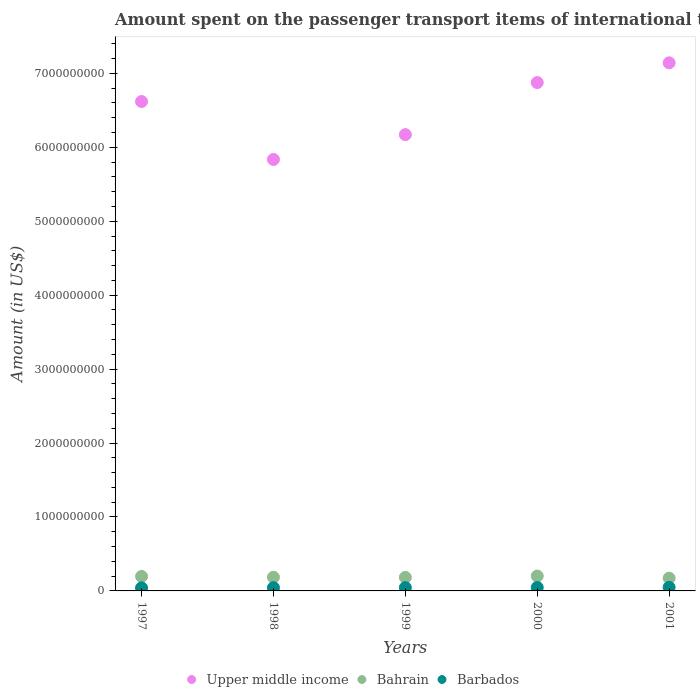Is the number of dotlines equal to the number of legend labels?
Make the answer very short. Yes. What is the amount spent on the passenger transport items of international tourists in Bahrain in 1999?
Offer a terse response. 1.83e+08. Across all years, what is the maximum amount spent on the passenger transport items of international tourists in Barbados?
Offer a terse response. 4.80e+07. Across all years, what is the minimum amount spent on the passenger transport items of international tourists in Upper middle income?
Provide a succinct answer. 5.84e+09. What is the total amount spent on the passenger transport items of international tourists in Bahrain in the graph?
Make the answer very short. 9.38e+08. What is the difference between the amount spent on the passenger transport items of international tourists in Barbados in 1997 and the amount spent on the passenger transport items of international tourists in Upper middle income in 2000?
Provide a short and direct response. -6.83e+09. What is the average amount spent on the passenger transport items of international tourists in Barbados per year?
Keep it short and to the point. 4.50e+07. In the year 1999, what is the difference between the amount spent on the passenger transport items of international tourists in Bahrain and amount spent on the passenger transport items of international tourists in Upper middle income?
Provide a succinct answer. -5.99e+09. In how many years, is the amount spent on the passenger transport items of international tourists in Barbados greater than 4800000000 US$?
Give a very brief answer. 0. What is the ratio of the amount spent on the passenger transport items of international tourists in Upper middle income in 1997 to that in 2000?
Provide a short and direct response. 0.96. Is the amount spent on the passenger transport items of international tourists in Bahrain in 1999 less than that in 2001?
Offer a very short reply. No. Is the difference between the amount spent on the passenger transport items of international tourists in Bahrain in 1997 and 1998 greater than the difference between the amount spent on the passenger transport items of international tourists in Upper middle income in 1997 and 1998?
Offer a very short reply. No. What is the difference between the highest and the second highest amount spent on the passenger transport items of international tourists in Bahrain?
Give a very brief answer. 5.00e+06. In how many years, is the amount spent on the passenger transport items of international tourists in Barbados greater than the average amount spent on the passenger transport items of international tourists in Barbados taken over all years?
Offer a very short reply. 2. Is the sum of the amount spent on the passenger transport items of international tourists in Barbados in 1997 and 2001 greater than the maximum amount spent on the passenger transport items of international tourists in Upper middle income across all years?
Give a very brief answer. No. Is it the case that in every year, the sum of the amount spent on the passenger transport items of international tourists in Barbados and amount spent on the passenger transport items of international tourists in Bahrain  is greater than the amount spent on the passenger transport items of international tourists in Upper middle income?
Make the answer very short. No. Is the amount spent on the passenger transport items of international tourists in Barbados strictly greater than the amount spent on the passenger transport items of international tourists in Upper middle income over the years?
Offer a terse response. No. What is the difference between two consecutive major ticks on the Y-axis?
Offer a very short reply. 1.00e+09. Are the values on the major ticks of Y-axis written in scientific E-notation?
Provide a succinct answer. No. Does the graph contain any zero values?
Make the answer very short. No. How are the legend labels stacked?
Your answer should be compact. Horizontal. What is the title of the graph?
Provide a succinct answer. Amount spent on the passenger transport items of international tourists. What is the Amount (in US$) of Upper middle income in 1997?
Your answer should be very brief. 6.62e+09. What is the Amount (in US$) in Bahrain in 1997?
Keep it short and to the point. 1.96e+08. What is the Amount (in US$) in Barbados in 1997?
Offer a terse response. 4.10e+07. What is the Amount (in US$) of Upper middle income in 1998?
Provide a succinct answer. 5.84e+09. What is the Amount (in US$) in Bahrain in 1998?
Provide a short and direct response. 1.85e+08. What is the Amount (in US$) of Barbados in 1998?
Your answer should be compact. 4.40e+07. What is the Amount (in US$) of Upper middle income in 1999?
Your answer should be very brief. 6.17e+09. What is the Amount (in US$) in Bahrain in 1999?
Offer a terse response. 1.83e+08. What is the Amount (in US$) of Barbados in 1999?
Offer a terse response. 4.50e+07. What is the Amount (in US$) in Upper middle income in 2000?
Your answer should be compact. 6.88e+09. What is the Amount (in US$) in Bahrain in 2000?
Your answer should be compact. 2.01e+08. What is the Amount (in US$) of Barbados in 2000?
Your answer should be compact. 4.70e+07. What is the Amount (in US$) in Upper middle income in 2001?
Provide a short and direct response. 7.14e+09. What is the Amount (in US$) of Bahrain in 2001?
Give a very brief answer. 1.73e+08. What is the Amount (in US$) of Barbados in 2001?
Provide a succinct answer. 4.80e+07. Across all years, what is the maximum Amount (in US$) of Upper middle income?
Provide a short and direct response. 7.14e+09. Across all years, what is the maximum Amount (in US$) in Bahrain?
Your response must be concise. 2.01e+08. Across all years, what is the maximum Amount (in US$) of Barbados?
Offer a very short reply. 4.80e+07. Across all years, what is the minimum Amount (in US$) of Upper middle income?
Your answer should be compact. 5.84e+09. Across all years, what is the minimum Amount (in US$) in Bahrain?
Offer a very short reply. 1.73e+08. Across all years, what is the minimum Amount (in US$) of Barbados?
Provide a succinct answer. 4.10e+07. What is the total Amount (in US$) in Upper middle income in the graph?
Offer a very short reply. 3.26e+1. What is the total Amount (in US$) in Bahrain in the graph?
Ensure brevity in your answer.  9.38e+08. What is the total Amount (in US$) of Barbados in the graph?
Offer a terse response. 2.25e+08. What is the difference between the Amount (in US$) in Upper middle income in 1997 and that in 1998?
Your answer should be very brief. 7.84e+08. What is the difference between the Amount (in US$) of Bahrain in 1997 and that in 1998?
Your response must be concise. 1.10e+07. What is the difference between the Amount (in US$) of Upper middle income in 1997 and that in 1999?
Your answer should be compact. 4.48e+08. What is the difference between the Amount (in US$) in Bahrain in 1997 and that in 1999?
Ensure brevity in your answer.  1.30e+07. What is the difference between the Amount (in US$) of Barbados in 1997 and that in 1999?
Your answer should be compact. -4.00e+06. What is the difference between the Amount (in US$) of Upper middle income in 1997 and that in 2000?
Offer a terse response. -2.57e+08. What is the difference between the Amount (in US$) in Bahrain in 1997 and that in 2000?
Provide a succinct answer. -5.00e+06. What is the difference between the Amount (in US$) of Barbados in 1997 and that in 2000?
Make the answer very short. -6.00e+06. What is the difference between the Amount (in US$) in Upper middle income in 1997 and that in 2001?
Ensure brevity in your answer.  -5.23e+08. What is the difference between the Amount (in US$) of Bahrain in 1997 and that in 2001?
Make the answer very short. 2.30e+07. What is the difference between the Amount (in US$) of Barbados in 1997 and that in 2001?
Make the answer very short. -7.00e+06. What is the difference between the Amount (in US$) in Upper middle income in 1998 and that in 1999?
Your answer should be very brief. -3.36e+08. What is the difference between the Amount (in US$) of Barbados in 1998 and that in 1999?
Keep it short and to the point. -1.00e+06. What is the difference between the Amount (in US$) in Upper middle income in 1998 and that in 2000?
Your answer should be compact. -1.04e+09. What is the difference between the Amount (in US$) in Bahrain in 1998 and that in 2000?
Your answer should be very brief. -1.60e+07. What is the difference between the Amount (in US$) in Barbados in 1998 and that in 2000?
Offer a terse response. -3.00e+06. What is the difference between the Amount (in US$) in Upper middle income in 1998 and that in 2001?
Keep it short and to the point. -1.31e+09. What is the difference between the Amount (in US$) in Barbados in 1998 and that in 2001?
Keep it short and to the point. -4.00e+06. What is the difference between the Amount (in US$) of Upper middle income in 1999 and that in 2000?
Ensure brevity in your answer.  -7.05e+08. What is the difference between the Amount (in US$) in Bahrain in 1999 and that in 2000?
Your answer should be compact. -1.80e+07. What is the difference between the Amount (in US$) in Barbados in 1999 and that in 2000?
Keep it short and to the point. -2.00e+06. What is the difference between the Amount (in US$) in Upper middle income in 1999 and that in 2001?
Offer a very short reply. -9.71e+08. What is the difference between the Amount (in US$) in Bahrain in 1999 and that in 2001?
Provide a short and direct response. 1.00e+07. What is the difference between the Amount (in US$) in Upper middle income in 2000 and that in 2001?
Your answer should be very brief. -2.67e+08. What is the difference between the Amount (in US$) of Bahrain in 2000 and that in 2001?
Offer a very short reply. 2.80e+07. What is the difference between the Amount (in US$) in Upper middle income in 1997 and the Amount (in US$) in Bahrain in 1998?
Offer a terse response. 6.43e+09. What is the difference between the Amount (in US$) in Upper middle income in 1997 and the Amount (in US$) in Barbados in 1998?
Keep it short and to the point. 6.57e+09. What is the difference between the Amount (in US$) in Bahrain in 1997 and the Amount (in US$) in Barbados in 1998?
Your response must be concise. 1.52e+08. What is the difference between the Amount (in US$) in Upper middle income in 1997 and the Amount (in US$) in Bahrain in 1999?
Your response must be concise. 6.44e+09. What is the difference between the Amount (in US$) of Upper middle income in 1997 and the Amount (in US$) of Barbados in 1999?
Your answer should be compact. 6.57e+09. What is the difference between the Amount (in US$) of Bahrain in 1997 and the Amount (in US$) of Barbados in 1999?
Ensure brevity in your answer.  1.51e+08. What is the difference between the Amount (in US$) in Upper middle income in 1997 and the Amount (in US$) in Bahrain in 2000?
Ensure brevity in your answer.  6.42e+09. What is the difference between the Amount (in US$) in Upper middle income in 1997 and the Amount (in US$) in Barbados in 2000?
Provide a short and direct response. 6.57e+09. What is the difference between the Amount (in US$) of Bahrain in 1997 and the Amount (in US$) of Barbados in 2000?
Provide a succinct answer. 1.49e+08. What is the difference between the Amount (in US$) of Upper middle income in 1997 and the Amount (in US$) of Bahrain in 2001?
Make the answer very short. 6.45e+09. What is the difference between the Amount (in US$) in Upper middle income in 1997 and the Amount (in US$) in Barbados in 2001?
Your response must be concise. 6.57e+09. What is the difference between the Amount (in US$) in Bahrain in 1997 and the Amount (in US$) in Barbados in 2001?
Offer a terse response. 1.48e+08. What is the difference between the Amount (in US$) in Upper middle income in 1998 and the Amount (in US$) in Bahrain in 1999?
Provide a short and direct response. 5.65e+09. What is the difference between the Amount (in US$) in Upper middle income in 1998 and the Amount (in US$) in Barbados in 1999?
Your answer should be very brief. 5.79e+09. What is the difference between the Amount (in US$) of Bahrain in 1998 and the Amount (in US$) of Barbados in 1999?
Keep it short and to the point. 1.40e+08. What is the difference between the Amount (in US$) in Upper middle income in 1998 and the Amount (in US$) in Bahrain in 2000?
Provide a short and direct response. 5.63e+09. What is the difference between the Amount (in US$) in Upper middle income in 1998 and the Amount (in US$) in Barbados in 2000?
Give a very brief answer. 5.79e+09. What is the difference between the Amount (in US$) of Bahrain in 1998 and the Amount (in US$) of Barbados in 2000?
Ensure brevity in your answer.  1.38e+08. What is the difference between the Amount (in US$) of Upper middle income in 1998 and the Amount (in US$) of Bahrain in 2001?
Your answer should be compact. 5.66e+09. What is the difference between the Amount (in US$) of Upper middle income in 1998 and the Amount (in US$) of Barbados in 2001?
Your answer should be very brief. 5.79e+09. What is the difference between the Amount (in US$) of Bahrain in 1998 and the Amount (in US$) of Barbados in 2001?
Provide a succinct answer. 1.37e+08. What is the difference between the Amount (in US$) of Upper middle income in 1999 and the Amount (in US$) of Bahrain in 2000?
Give a very brief answer. 5.97e+09. What is the difference between the Amount (in US$) in Upper middle income in 1999 and the Amount (in US$) in Barbados in 2000?
Offer a very short reply. 6.12e+09. What is the difference between the Amount (in US$) in Bahrain in 1999 and the Amount (in US$) in Barbados in 2000?
Offer a terse response. 1.36e+08. What is the difference between the Amount (in US$) of Upper middle income in 1999 and the Amount (in US$) of Bahrain in 2001?
Offer a terse response. 6.00e+09. What is the difference between the Amount (in US$) in Upper middle income in 1999 and the Amount (in US$) in Barbados in 2001?
Provide a short and direct response. 6.12e+09. What is the difference between the Amount (in US$) in Bahrain in 1999 and the Amount (in US$) in Barbados in 2001?
Your answer should be compact. 1.35e+08. What is the difference between the Amount (in US$) in Upper middle income in 2000 and the Amount (in US$) in Bahrain in 2001?
Your answer should be very brief. 6.70e+09. What is the difference between the Amount (in US$) in Upper middle income in 2000 and the Amount (in US$) in Barbados in 2001?
Ensure brevity in your answer.  6.83e+09. What is the difference between the Amount (in US$) of Bahrain in 2000 and the Amount (in US$) of Barbados in 2001?
Make the answer very short. 1.53e+08. What is the average Amount (in US$) in Upper middle income per year?
Your response must be concise. 6.53e+09. What is the average Amount (in US$) of Bahrain per year?
Your answer should be compact. 1.88e+08. What is the average Amount (in US$) of Barbados per year?
Provide a short and direct response. 4.50e+07. In the year 1997, what is the difference between the Amount (in US$) in Upper middle income and Amount (in US$) in Bahrain?
Your response must be concise. 6.42e+09. In the year 1997, what is the difference between the Amount (in US$) in Upper middle income and Amount (in US$) in Barbados?
Offer a terse response. 6.58e+09. In the year 1997, what is the difference between the Amount (in US$) in Bahrain and Amount (in US$) in Barbados?
Make the answer very short. 1.55e+08. In the year 1998, what is the difference between the Amount (in US$) of Upper middle income and Amount (in US$) of Bahrain?
Your answer should be very brief. 5.65e+09. In the year 1998, what is the difference between the Amount (in US$) of Upper middle income and Amount (in US$) of Barbados?
Your answer should be compact. 5.79e+09. In the year 1998, what is the difference between the Amount (in US$) of Bahrain and Amount (in US$) of Barbados?
Offer a terse response. 1.41e+08. In the year 1999, what is the difference between the Amount (in US$) in Upper middle income and Amount (in US$) in Bahrain?
Your answer should be compact. 5.99e+09. In the year 1999, what is the difference between the Amount (in US$) in Upper middle income and Amount (in US$) in Barbados?
Make the answer very short. 6.13e+09. In the year 1999, what is the difference between the Amount (in US$) of Bahrain and Amount (in US$) of Barbados?
Your response must be concise. 1.38e+08. In the year 2000, what is the difference between the Amount (in US$) in Upper middle income and Amount (in US$) in Bahrain?
Ensure brevity in your answer.  6.67e+09. In the year 2000, what is the difference between the Amount (in US$) in Upper middle income and Amount (in US$) in Barbados?
Provide a short and direct response. 6.83e+09. In the year 2000, what is the difference between the Amount (in US$) of Bahrain and Amount (in US$) of Barbados?
Your response must be concise. 1.54e+08. In the year 2001, what is the difference between the Amount (in US$) of Upper middle income and Amount (in US$) of Bahrain?
Make the answer very short. 6.97e+09. In the year 2001, what is the difference between the Amount (in US$) in Upper middle income and Amount (in US$) in Barbados?
Provide a short and direct response. 7.09e+09. In the year 2001, what is the difference between the Amount (in US$) in Bahrain and Amount (in US$) in Barbados?
Keep it short and to the point. 1.25e+08. What is the ratio of the Amount (in US$) in Upper middle income in 1997 to that in 1998?
Provide a succinct answer. 1.13. What is the ratio of the Amount (in US$) of Bahrain in 1997 to that in 1998?
Keep it short and to the point. 1.06. What is the ratio of the Amount (in US$) of Barbados in 1997 to that in 1998?
Provide a short and direct response. 0.93. What is the ratio of the Amount (in US$) of Upper middle income in 1997 to that in 1999?
Keep it short and to the point. 1.07. What is the ratio of the Amount (in US$) of Bahrain in 1997 to that in 1999?
Your response must be concise. 1.07. What is the ratio of the Amount (in US$) of Barbados in 1997 to that in 1999?
Give a very brief answer. 0.91. What is the ratio of the Amount (in US$) of Upper middle income in 1997 to that in 2000?
Provide a succinct answer. 0.96. What is the ratio of the Amount (in US$) in Bahrain in 1997 to that in 2000?
Your response must be concise. 0.98. What is the ratio of the Amount (in US$) of Barbados in 1997 to that in 2000?
Ensure brevity in your answer.  0.87. What is the ratio of the Amount (in US$) of Upper middle income in 1997 to that in 2001?
Provide a short and direct response. 0.93. What is the ratio of the Amount (in US$) of Bahrain in 1997 to that in 2001?
Keep it short and to the point. 1.13. What is the ratio of the Amount (in US$) of Barbados in 1997 to that in 2001?
Give a very brief answer. 0.85. What is the ratio of the Amount (in US$) of Upper middle income in 1998 to that in 1999?
Your answer should be compact. 0.95. What is the ratio of the Amount (in US$) in Bahrain in 1998 to that in 1999?
Your response must be concise. 1.01. What is the ratio of the Amount (in US$) in Barbados in 1998 to that in 1999?
Your answer should be very brief. 0.98. What is the ratio of the Amount (in US$) in Upper middle income in 1998 to that in 2000?
Keep it short and to the point. 0.85. What is the ratio of the Amount (in US$) in Bahrain in 1998 to that in 2000?
Make the answer very short. 0.92. What is the ratio of the Amount (in US$) in Barbados in 1998 to that in 2000?
Provide a succinct answer. 0.94. What is the ratio of the Amount (in US$) in Upper middle income in 1998 to that in 2001?
Offer a terse response. 0.82. What is the ratio of the Amount (in US$) of Bahrain in 1998 to that in 2001?
Your response must be concise. 1.07. What is the ratio of the Amount (in US$) in Upper middle income in 1999 to that in 2000?
Your answer should be compact. 0.9. What is the ratio of the Amount (in US$) of Bahrain in 1999 to that in 2000?
Ensure brevity in your answer.  0.91. What is the ratio of the Amount (in US$) of Barbados in 1999 to that in 2000?
Your answer should be very brief. 0.96. What is the ratio of the Amount (in US$) in Upper middle income in 1999 to that in 2001?
Provide a short and direct response. 0.86. What is the ratio of the Amount (in US$) of Bahrain in 1999 to that in 2001?
Provide a short and direct response. 1.06. What is the ratio of the Amount (in US$) of Upper middle income in 2000 to that in 2001?
Your answer should be compact. 0.96. What is the ratio of the Amount (in US$) of Bahrain in 2000 to that in 2001?
Keep it short and to the point. 1.16. What is the ratio of the Amount (in US$) of Barbados in 2000 to that in 2001?
Provide a succinct answer. 0.98. What is the difference between the highest and the second highest Amount (in US$) of Upper middle income?
Keep it short and to the point. 2.67e+08. What is the difference between the highest and the second highest Amount (in US$) in Bahrain?
Make the answer very short. 5.00e+06. What is the difference between the highest and the lowest Amount (in US$) in Upper middle income?
Your answer should be very brief. 1.31e+09. What is the difference between the highest and the lowest Amount (in US$) of Bahrain?
Offer a very short reply. 2.80e+07. 